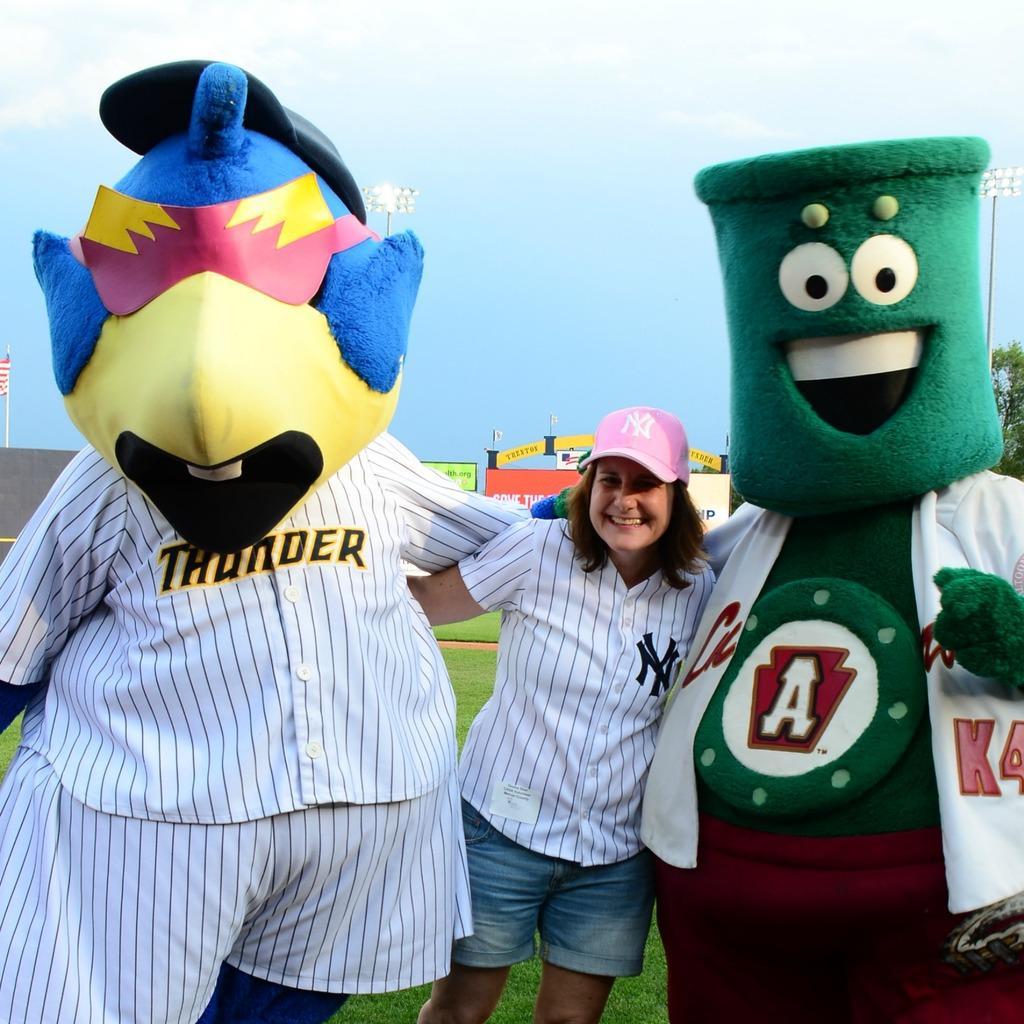In one or two sentences, can you explain what this image depicts? In the center of the image we can see a lady is standing and smiling and wearing a cap and also we can see the clowns. In the background of the image we can see the wall, boards, flagpoles, tree, grass, electric light poles. At the top of the image we can see the clouds are present in the sky. At the bottom of the image we can see the ground. 